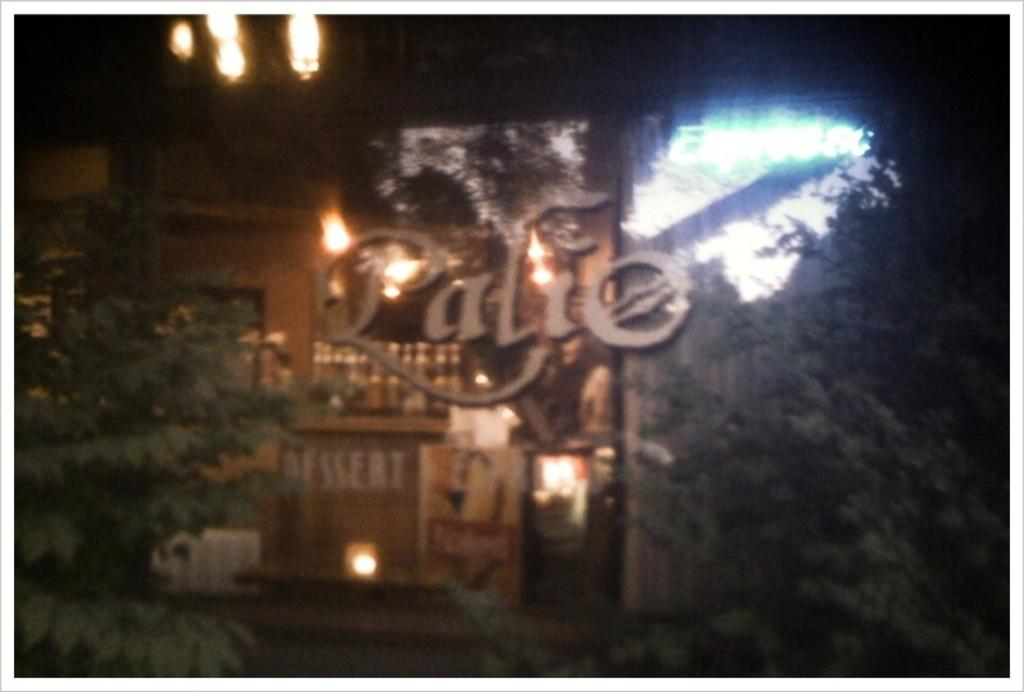What type of establishment is shown in the image? The image depicts a store. Can you describe any specific features on the left side of the image? There are lights on the left side of the image. What natural element can be seen in the image? There is a tree in the image. Can you tell me how many toes are visible on the receipt in the image? There is no receipt present in the image, and therefore no toes can be seen on it. 